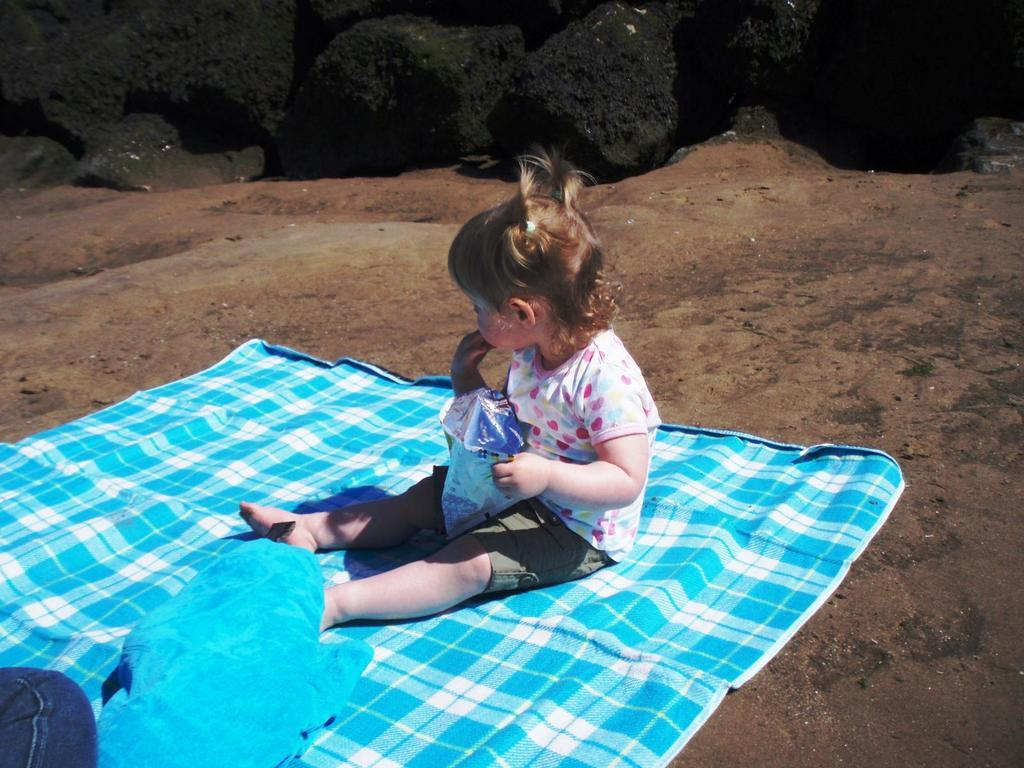What is the kid sitting on in the image? The kid is sitting on a cloth. What is the kid holding in the image? The kid is holding an object. What can be seen in the background of the image? Rocks are visible in the background of the image. How does the kid express regret in the image? There is no indication in the image that the kid is expressing regret. 